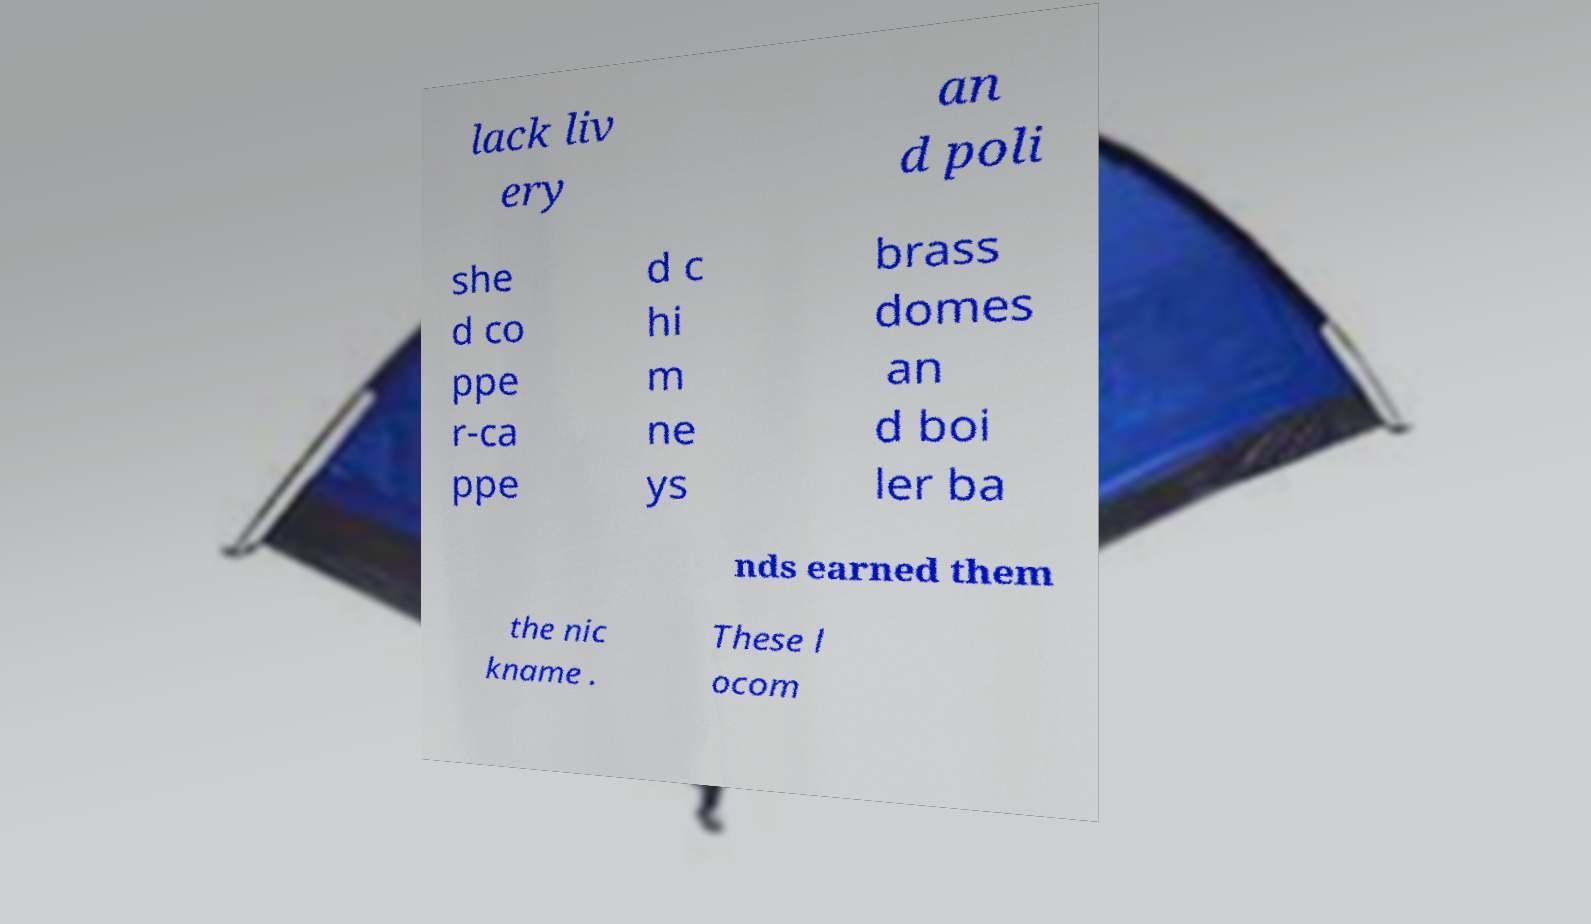Can you read and provide the text displayed in the image?This photo seems to have some interesting text. Can you extract and type it out for me? lack liv ery an d poli she d co ppe r-ca ppe d c hi m ne ys brass domes an d boi ler ba nds earned them the nic kname . These l ocom 